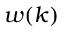Convert formula to latex. <formula><loc_0><loc_0><loc_500><loc_500>w ( k )</formula> 